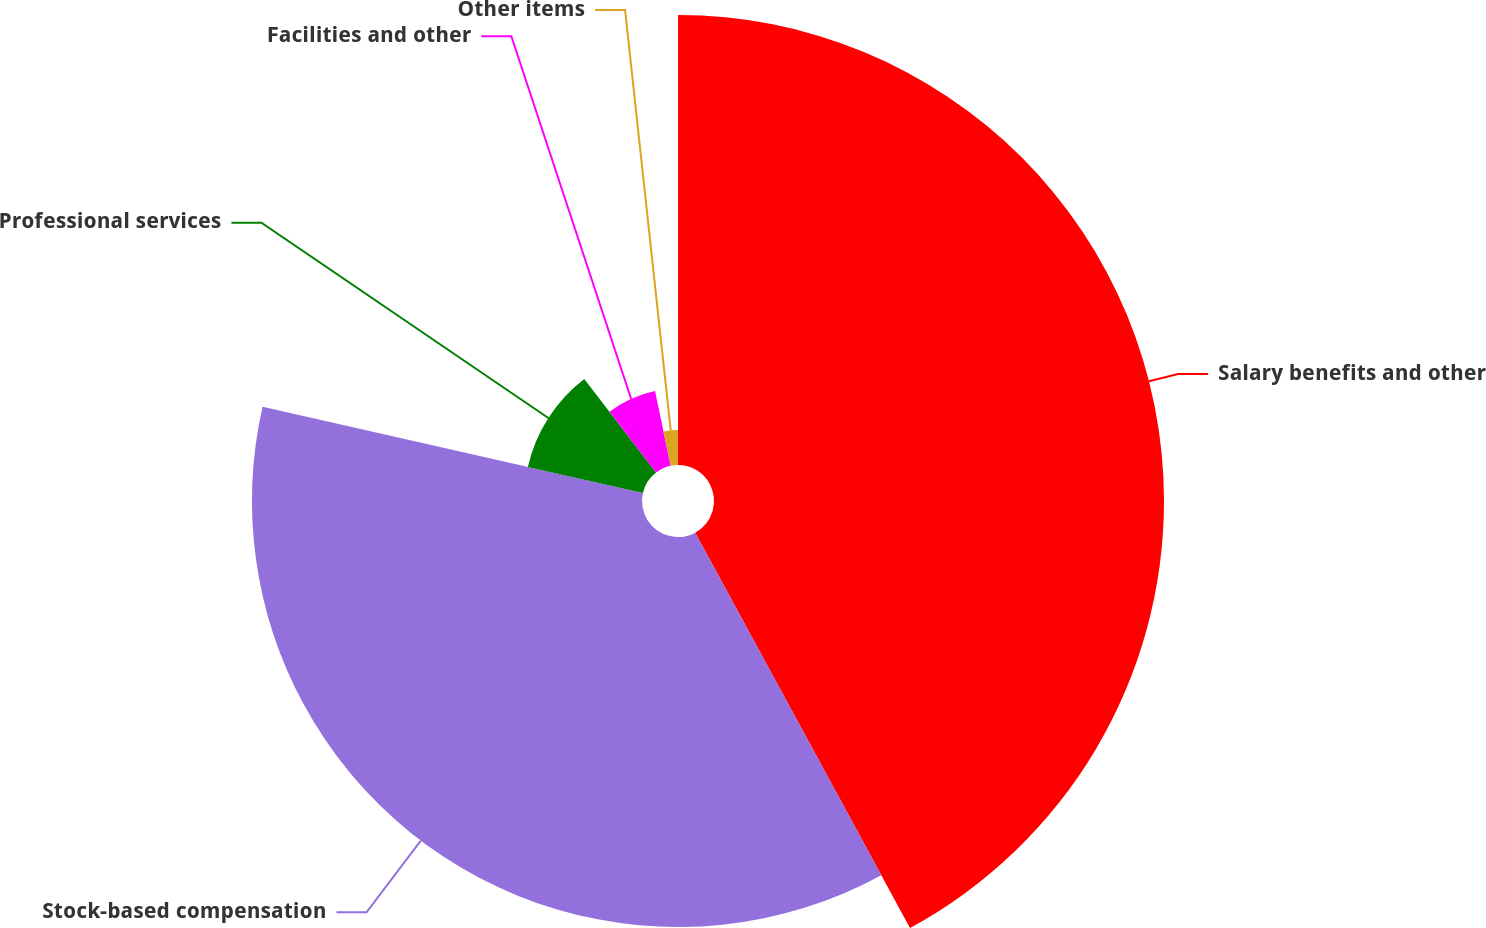Convert chart to OTSL. <chart><loc_0><loc_0><loc_500><loc_500><pie_chart><fcel>Salary benefits and other<fcel>Stock-based compensation<fcel>Professional services<fcel>Facilities and other<fcel>Other items<nl><fcel>42.08%<fcel>36.47%<fcel>11.03%<fcel>7.15%<fcel>3.27%<nl></chart> 